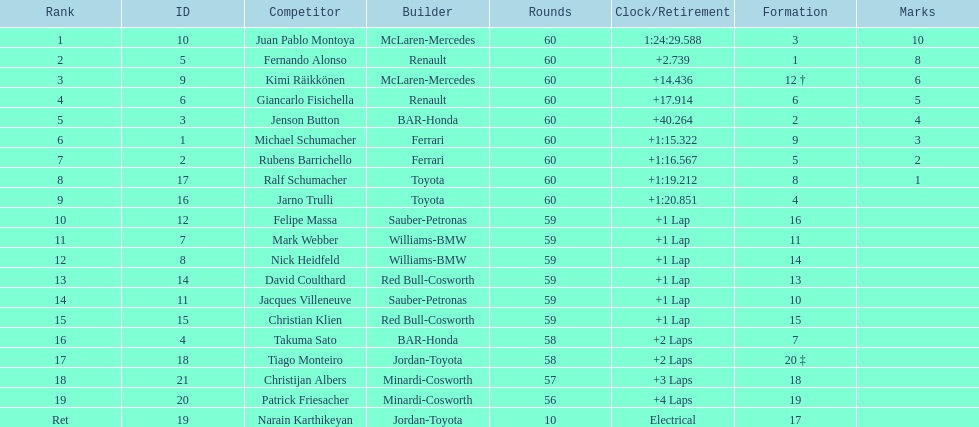How many drivers received points from the race? 8. 